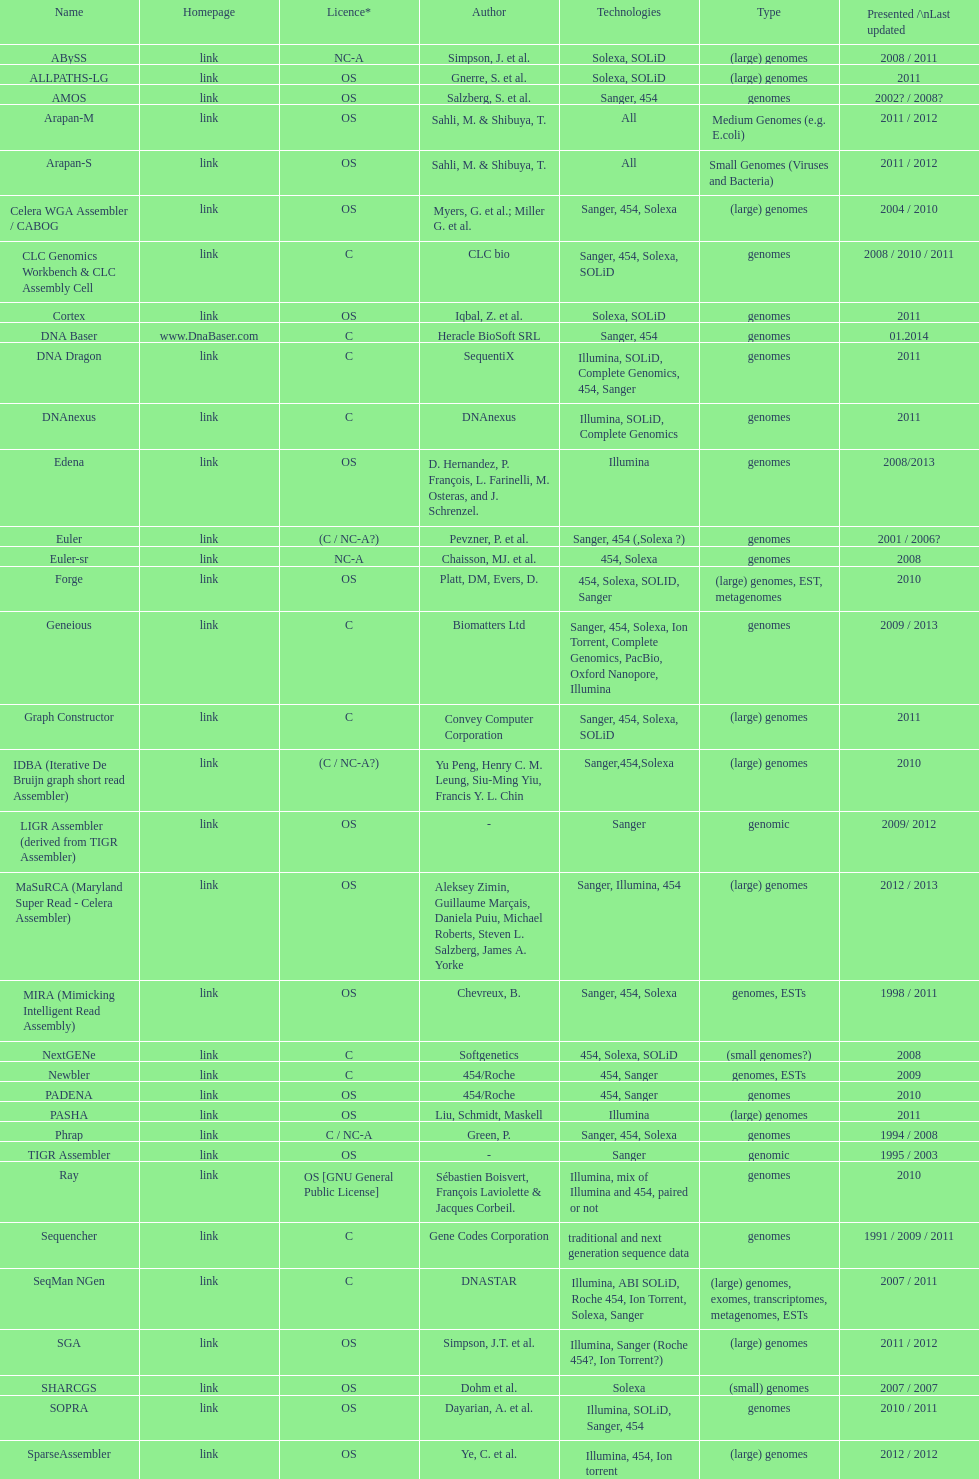What is the latest presentation or updated version? DNA Baser. 